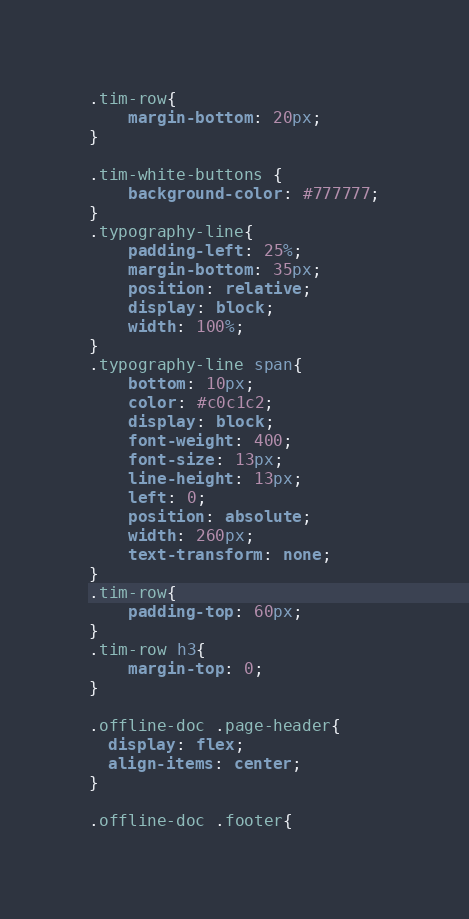Convert code to text. <code><loc_0><loc_0><loc_500><loc_500><_CSS_>.tim-row{
    margin-bottom: 20px;
}

.tim-white-buttons {
    background-color: #777777;
}
.typography-line{
    padding-left: 25%;
    margin-bottom: 35px;
    position: relative;
    display: block;
    width: 100%;
}
.typography-line span{
    bottom: 10px;
    color: #c0c1c2;
    display: block;
    font-weight: 400;
    font-size: 13px;
    line-height: 13px;
    left: 0;
    position: absolute;
    width: 260px;
    text-transform: none;
}
.tim-row{
    padding-top: 60px;
}
.tim-row h3{
    margin-top: 0;
}

.offline-doc .page-header{
  display: flex;
  align-items: center;
}

.offline-doc .footer{</code> 